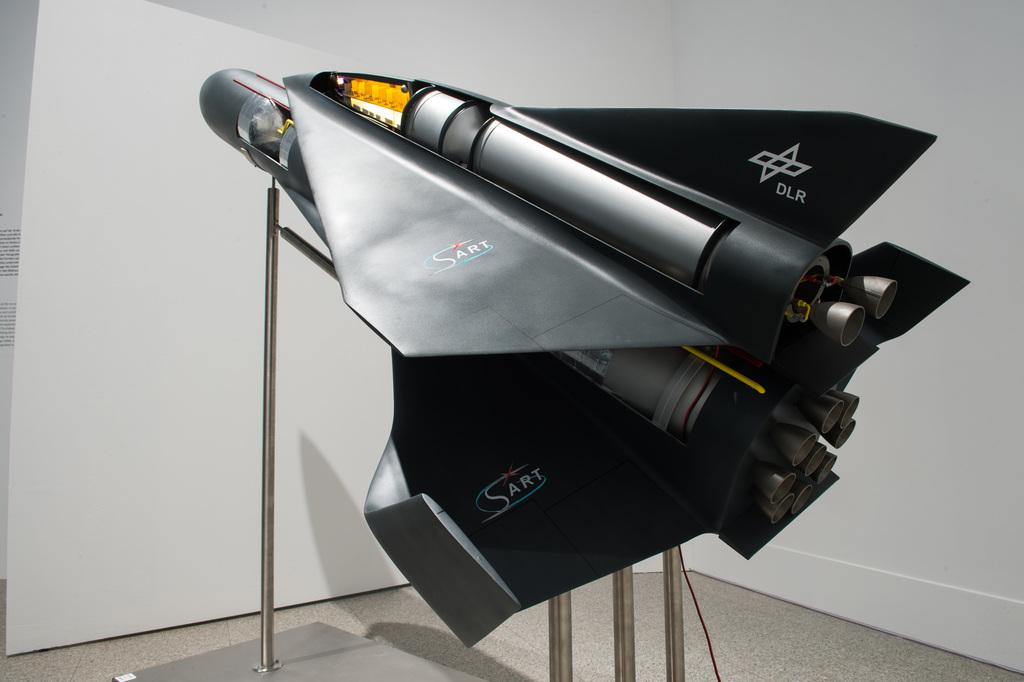<image>
Share a concise interpretation of the image provided. A SART rocket model sits on a display stand 